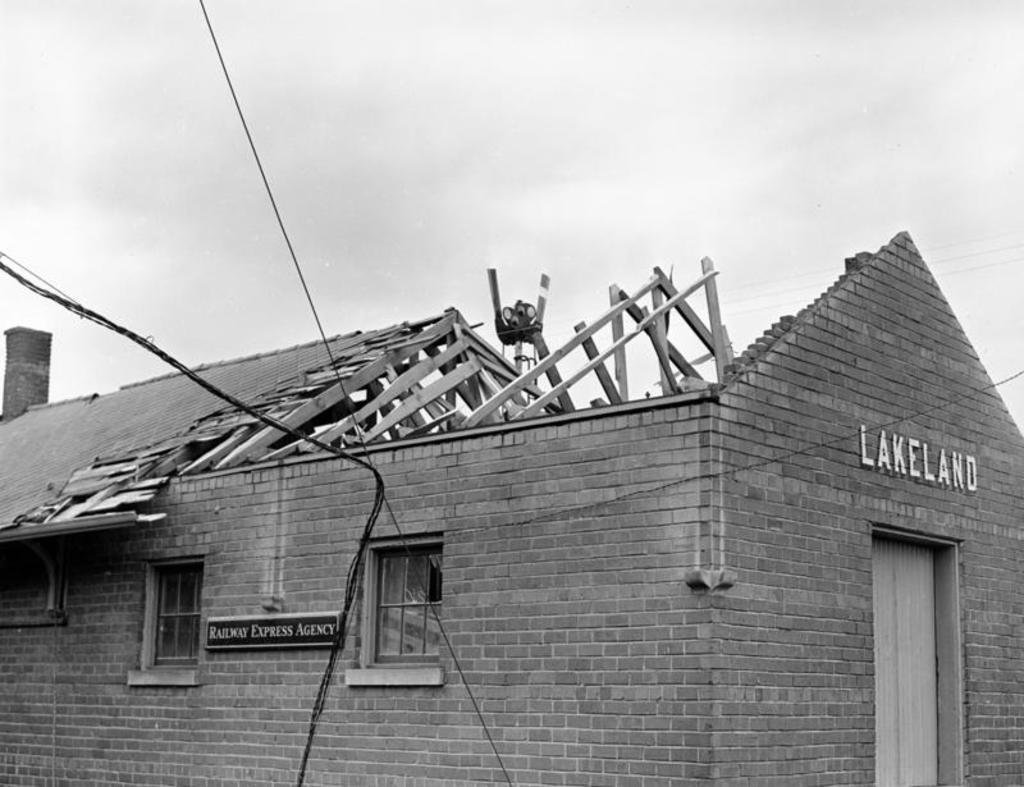What type of structure is in the image? There is a house in the image. What feature can be seen on the house? The house has windows. What is written or displayed on a board in the image? There is a board with text in the image. What can be seen in the sky in the image? The sky is visible in the image. What type of utility infrastructure is present in the image? Wires are present in the image. What type of material is visible in the image? Wooden sticks are visible in the image. What type of salt is being used to talk in the bedroom in the image? There is no salt, talking, or bedroom present in the image. 